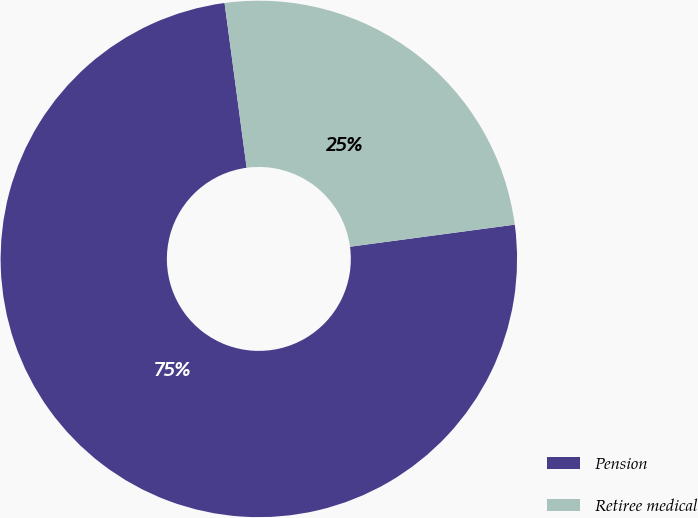Convert chart to OTSL. <chart><loc_0><loc_0><loc_500><loc_500><pie_chart><fcel>Pension<fcel>Retiree medical<nl><fcel>75.0%<fcel>25.0%<nl></chart> 